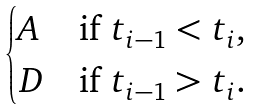<formula> <loc_0><loc_0><loc_500><loc_500>\begin{cases} A & \text {if $t_{i-1} < t_{i}$,} \\ D & \text {if $t_{i-1} > t_{i}$} . \end{cases}</formula> 